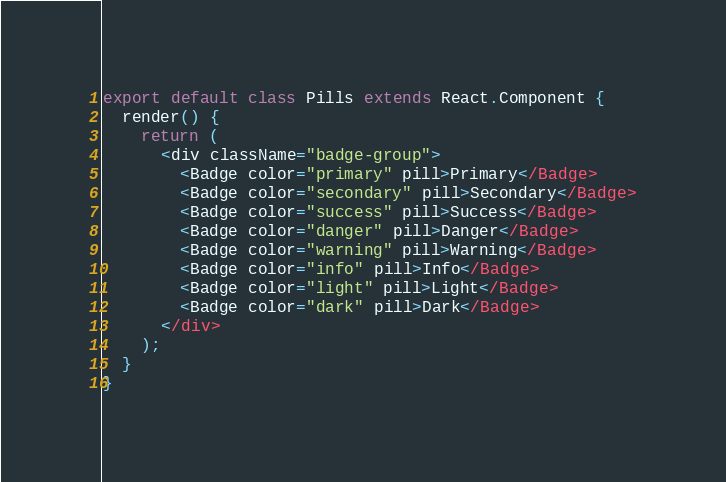<code> <loc_0><loc_0><loc_500><loc_500><_JavaScript_>export default class Pills extends React.Component {
  render() {
    return (
      <div className="badge-group">
        <Badge color="primary" pill>Primary</Badge>
        <Badge color="secondary" pill>Secondary</Badge>
        <Badge color="success" pill>Success</Badge>
        <Badge color="danger" pill>Danger</Badge>
        <Badge color="warning" pill>Warning</Badge>
        <Badge color="info" pill>Info</Badge>
        <Badge color="light" pill>Light</Badge>
        <Badge color="dark" pill>Dark</Badge>
      </div>
    );
  }
}</code> 